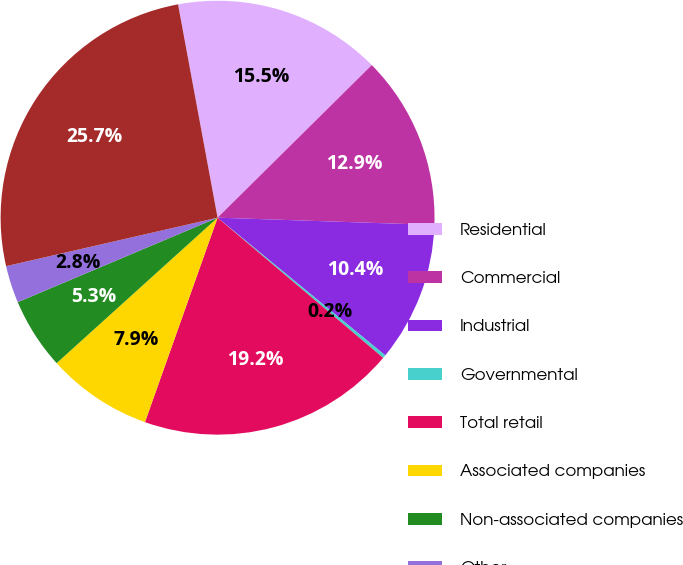Convert chart. <chart><loc_0><loc_0><loc_500><loc_500><pie_chart><fcel>Residential<fcel>Commercial<fcel>Industrial<fcel>Governmental<fcel>Total retail<fcel>Associated companies<fcel>Non-associated companies<fcel>Other<fcel>Total<nl><fcel>15.5%<fcel>12.95%<fcel>10.41%<fcel>0.24%<fcel>19.25%<fcel>7.87%<fcel>5.33%<fcel>2.78%<fcel>25.67%<nl></chart> 